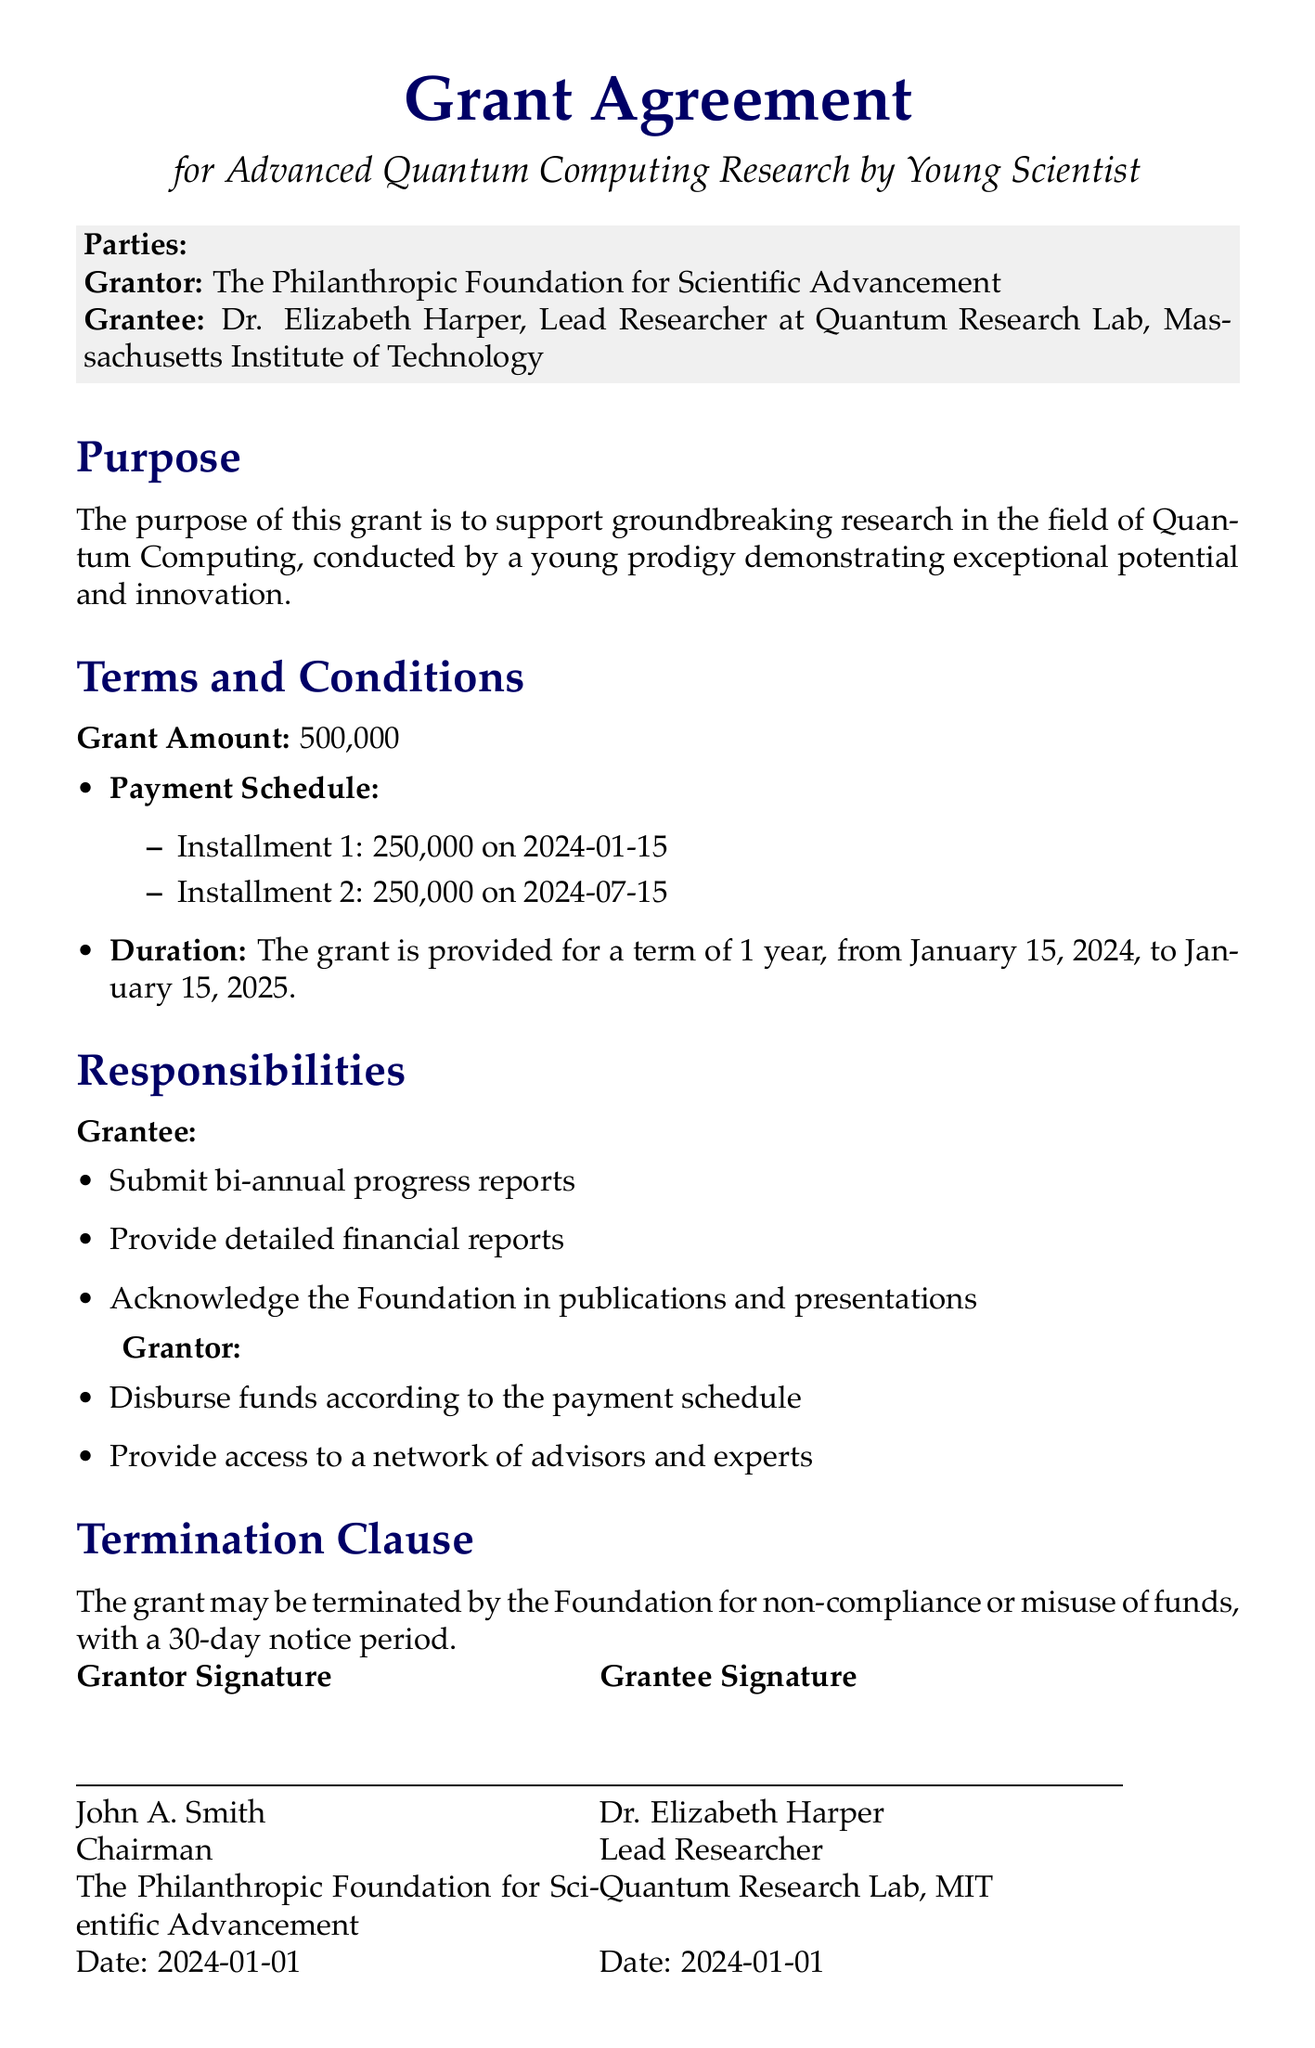What is the grant amount? The grant amount is specified as the total financial support provided by the foundation, which is $500,000.
Answer: $500,000 Who is the grantee? The grantee is the individual receiving the grant, identified as Dr. Elizabeth Harper, Lead Researcher at Quantum Research Lab, Massachusetts Institute of Technology.
Answer: Dr. Elizabeth Harper What is the purpose of the grant? The purpose of the grant is clearly stated in the document as supporting groundbreaking research in the field of Quantum Computing.
Answer: Support groundbreaking research When is the first payment scheduled? The document outlines a payment schedule, with the first installment occurring on January 15, 2024.
Answer: 2024-01-15 What are the responsibilities of the grantee? The grantee has several responsibilities, including submitting bi-annual progress reports, which are explicitly mentioned in the document.
Answer: Submit bi-annual progress reports How long is the duration of the grant? The duration of the grant is defined in the document, covering a term of one year from its start date.
Answer: 1 year Who signed the grant agreement on behalf of the foundation? The individual who signed the agreement is identified in the document as John A. Smith, the Chairman of the foundation.
Answer: John A. Smith What happens in case of non-compliance with the grant terms? The document specifies that the grant may be terminated by the Foundation for non-compliance or misuse of funds, indicating the consequences of such actions.
Answer: The grant may be terminated What is the second payment amount? The document details the payment schedule, indicating that the second installment is also set at $250,000.
Answer: 250,000 